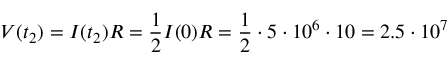<formula> <loc_0><loc_0><loc_500><loc_500>V ( t _ { 2 } ) = I ( t _ { 2 } ) R = \frac { 1 } { 2 } I ( 0 ) R = \frac { 1 } { 2 } \cdot 5 \cdot 1 0 ^ { 6 } \cdot 1 0 = 2 . 5 \cdot 1 0 ^ { 7 }</formula> 